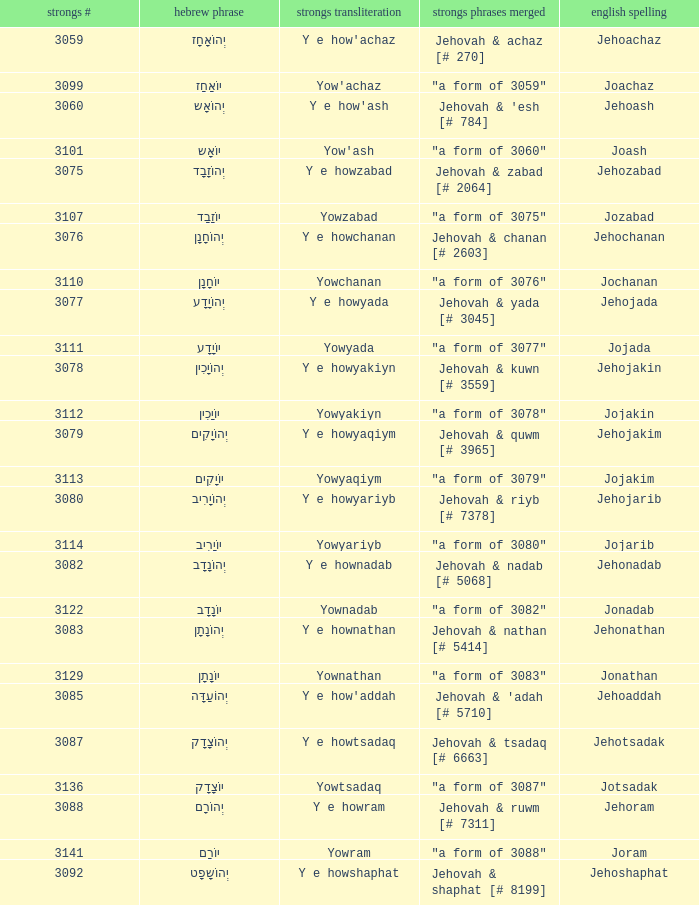What is the strongs # of the english spelling word jehojakin? 3078.0. 